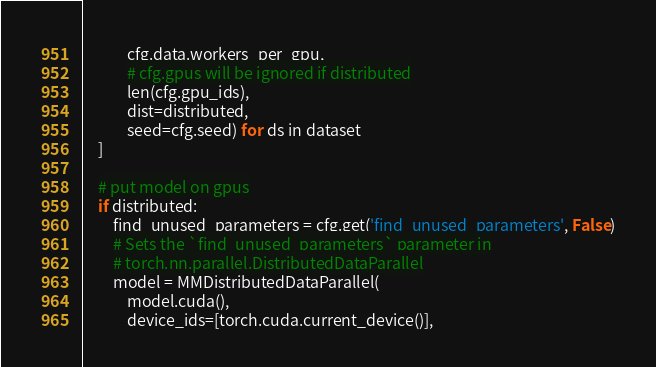Convert code to text. <code><loc_0><loc_0><loc_500><loc_500><_Python_>            cfg.data.workers_per_gpu,
            # cfg.gpus will be ignored if distributed
            len(cfg.gpu_ids),
            dist=distributed,
            seed=cfg.seed) for ds in dataset
    ]

    # put model on gpus
    if distributed:
        find_unused_parameters = cfg.get('find_unused_parameters', False)
        # Sets the `find_unused_parameters` parameter in
        # torch.nn.parallel.DistributedDataParallel
        model = MMDistributedDataParallel(
            model.cuda(),
            device_ids=[torch.cuda.current_device()],</code> 